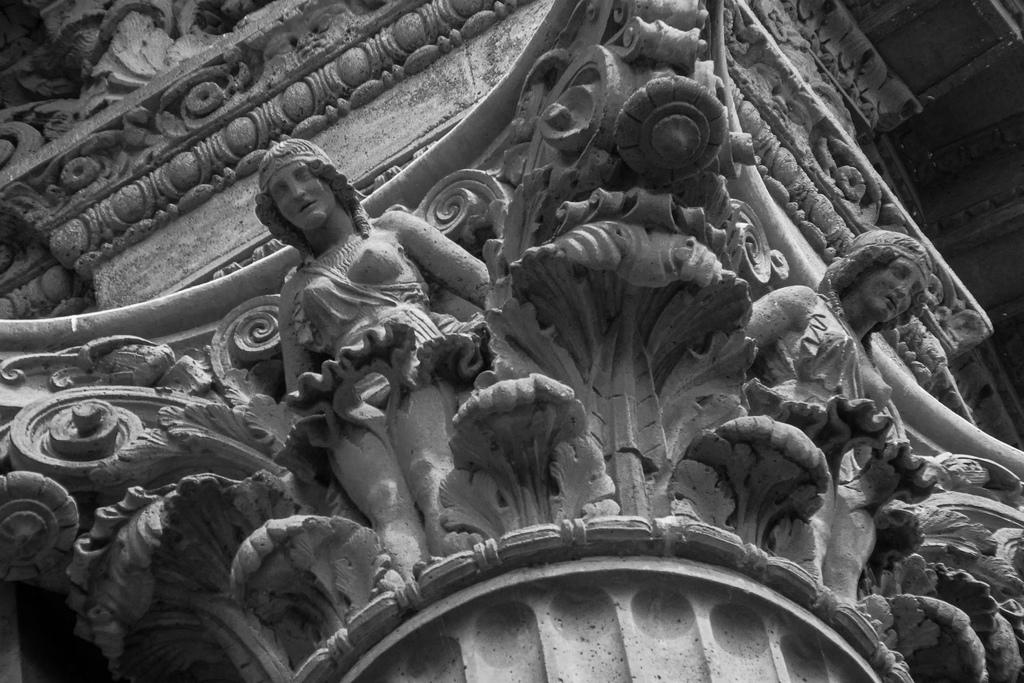What is depicted in the image? There are sculptures of two persons in the image. What else can be seen in the image? There is a wall in the image. Can you describe the setting of the image? The image appears to be taken near a church. How many kittens are present in the image? There are no kittens present in the image. What fact can be determined about the sculptures in the image? The provided facts do not mention any specific facts about the sculptures, so we cannot determine any facts about them from the information given. 